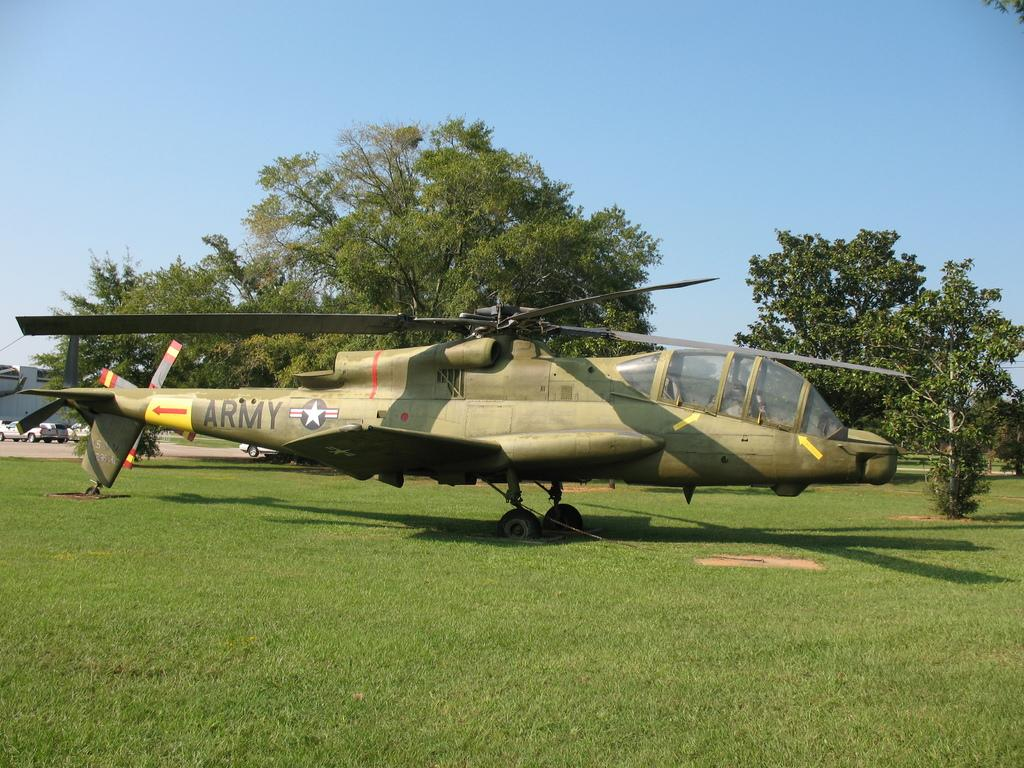Provide a one-sentence caption for the provided image. A helicopter with the word ARMY written across its tail. 